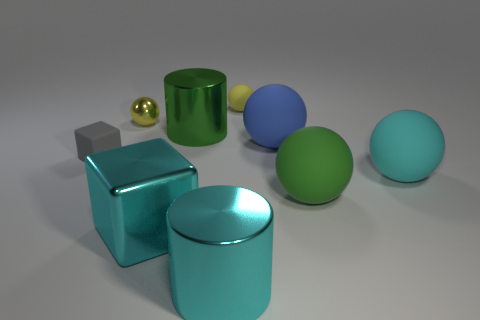Imagine these objects were part of a puzzle, how might they fit together? If these objects were part of a puzzle, it could be a spatial reasoning challenge. The spheres might fit into circular indentations, the cylinders into matching circular slots, and the cube could slot into a square recess. The objective would be to place each object in the corresponding space based on their shapes and maybe even color match. 